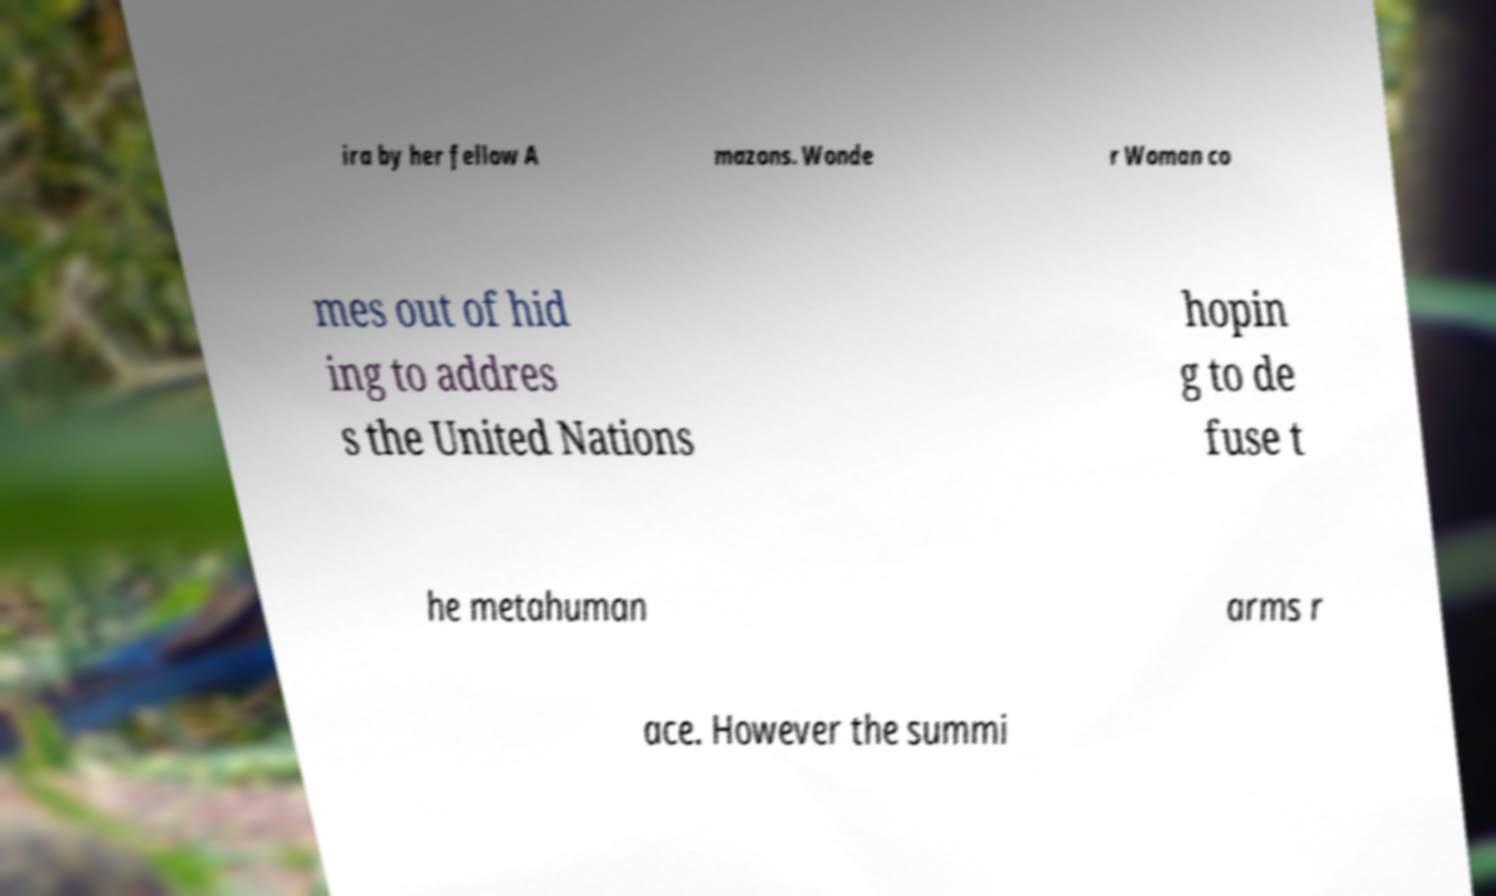Could you extract and type out the text from this image? ira by her fellow A mazons. Wonde r Woman co mes out of hid ing to addres s the United Nations hopin g to de fuse t he metahuman arms r ace. However the summi 